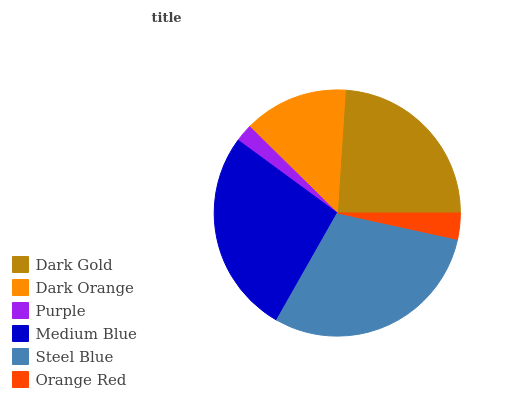Is Purple the minimum?
Answer yes or no. Yes. Is Steel Blue the maximum?
Answer yes or no. Yes. Is Dark Orange the minimum?
Answer yes or no. No. Is Dark Orange the maximum?
Answer yes or no. No. Is Dark Gold greater than Dark Orange?
Answer yes or no. Yes. Is Dark Orange less than Dark Gold?
Answer yes or no. Yes. Is Dark Orange greater than Dark Gold?
Answer yes or no. No. Is Dark Gold less than Dark Orange?
Answer yes or no. No. Is Dark Gold the high median?
Answer yes or no. Yes. Is Dark Orange the low median?
Answer yes or no. Yes. Is Steel Blue the high median?
Answer yes or no. No. Is Purple the low median?
Answer yes or no. No. 